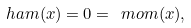Convert formula to latex. <formula><loc_0><loc_0><loc_500><loc_500>\ h a m ( x ) = 0 = \ m o m ( x ) ,</formula> 